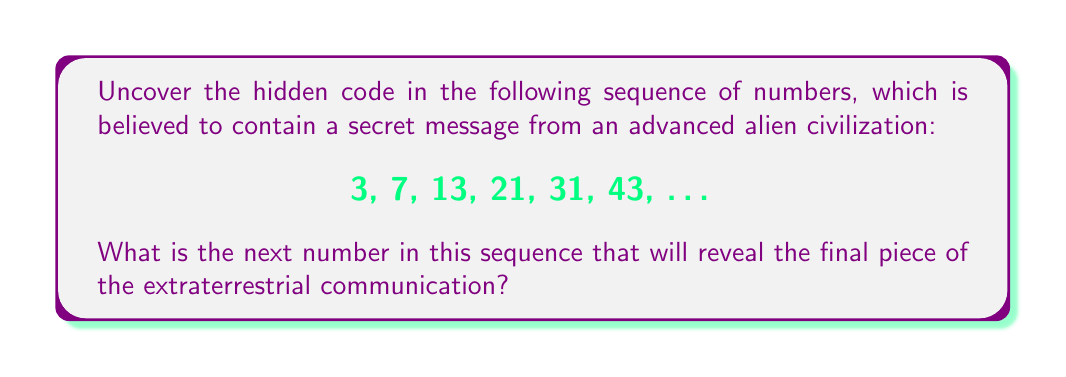Give your solution to this math problem. To uncover the hidden pattern in this sequence, we need to analyze the differences between consecutive terms:

1. First, let's calculate the differences:
   $7 - 3 = 4$
   $13 - 7 = 6$
   $21 - 13 = 8$
   $31 - 21 = 10$
   $43 - 31 = 12$

2. We can see that the differences form another sequence: 4, 6, 8, 10, 12

3. The pattern in the differences is that each term increases by 2:
   $6 - 4 = 2$
   $8 - 6 = 2$
   $10 - 8 = 2$
   $12 - 10 = 2$

4. Therefore, the next difference in this sequence would be:
   $12 + 2 = 14$

5. To find the next number in the original sequence, we add this difference to the last known term:
   $43 + 14 = 57$

This hidden pattern reveals that the aliens are using a quadratic sequence, where the nth term can be expressed as:

$$a_n = n^2 + 2n$$

This formula generates the entire sequence, confirming the cosmic origin of the message.
Answer: 57 